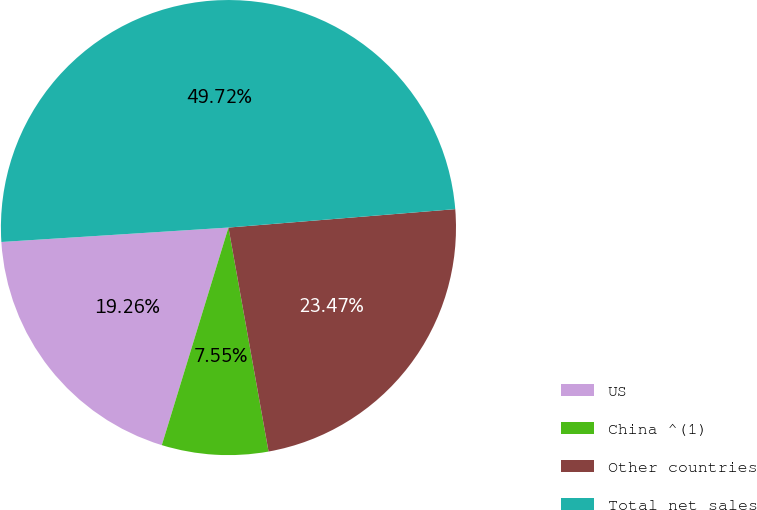Convert chart. <chart><loc_0><loc_0><loc_500><loc_500><pie_chart><fcel>US<fcel>China ^(1)<fcel>Other countries<fcel>Total net sales<nl><fcel>19.26%<fcel>7.55%<fcel>23.47%<fcel>49.72%<nl></chart> 